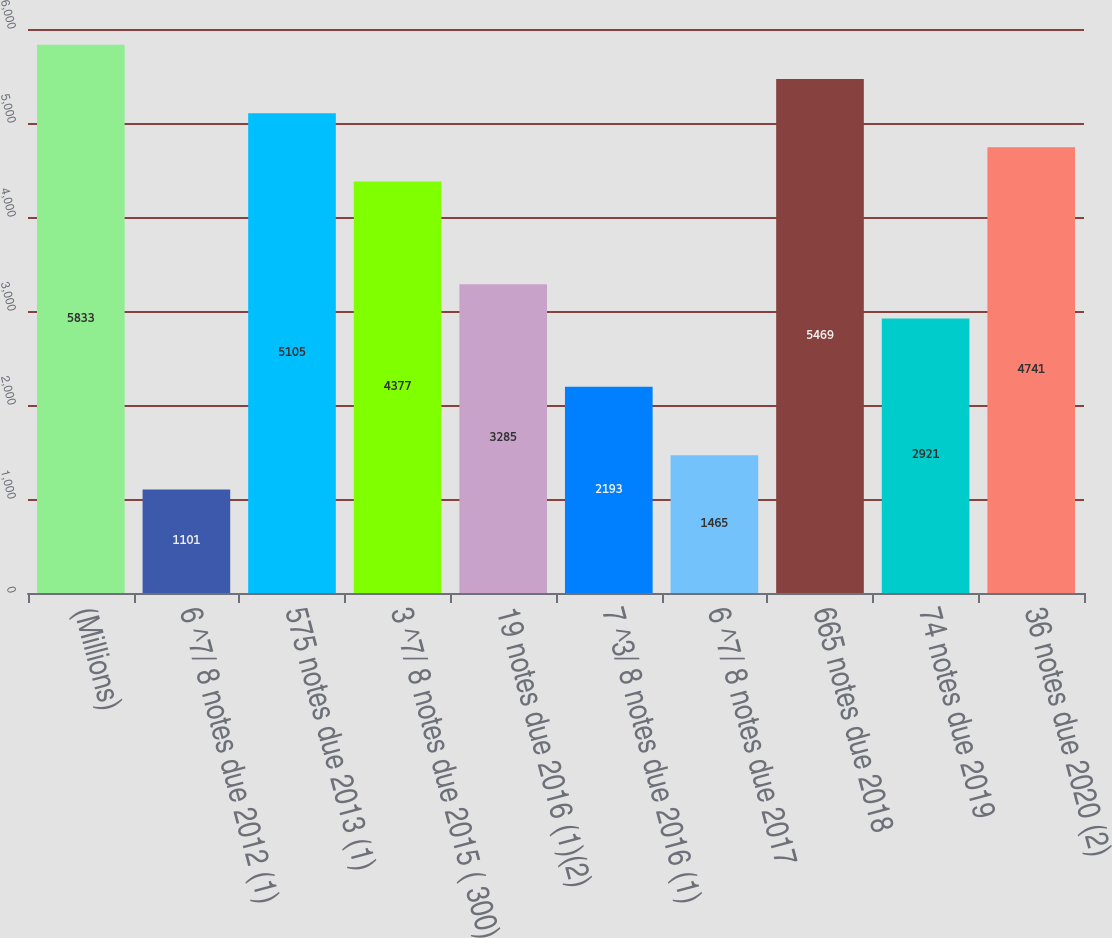Convert chart to OTSL. <chart><loc_0><loc_0><loc_500><loc_500><bar_chart><fcel>(Millions)<fcel>6 ^7/ 8 notes due 2012 (1)<fcel>575 notes due 2013 (1)<fcel>3 ^7/ 8 notes due 2015 ( 300)<fcel>19 notes due 2016 (1)(2)<fcel>7 ^3/ 8 notes due 2016 (1)<fcel>6 ^7/ 8 notes due 2017<fcel>665 notes due 2018<fcel>74 notes due 2019<fcel>36 notes due 2020 (2)<nl><fcel>5833<fcel>1101<fcel>5105<fcel>4377<fcel>3285<fcel>2193<fcel>1465<fcel>5469<fcel>2921<fcel>4741<nl></chart> 